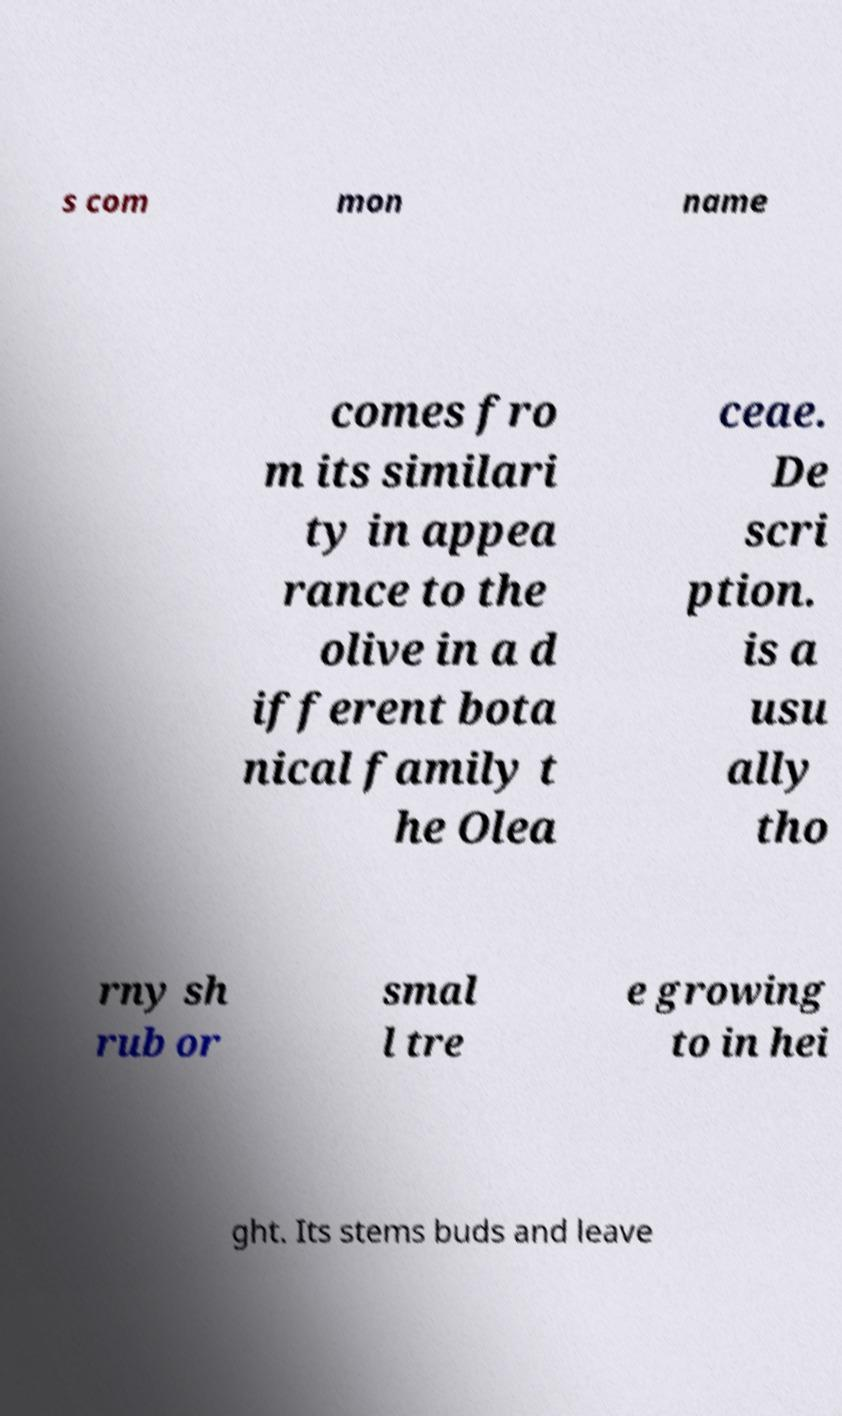There's text embedded in this image that I need extracted. Can you transcribe it verbatim? s com mon name comes fro m its similari ty in appea rance to the olive in a d ifferent bota nical family t he Olea ceae. De scri ption. is a usu ally tho rny sh rub or smal l tre e growing to in hei ght. Its stems buds and leave 